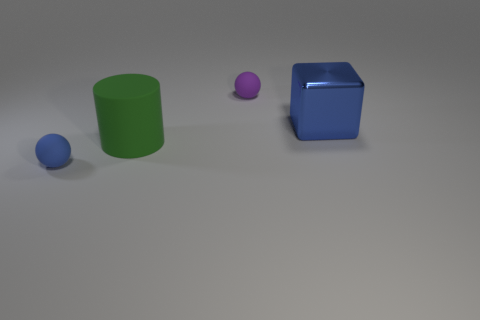What could be the potential use of these objects? The objects can be used for a variety of purposes, such as educational aids for teaching geometry and colors, props for a computer graphics project, or elements in a 3D modeling software tutorial. 